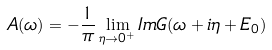Convert formula to latex. <formula><loc_0><loc_0><loc_500><loc_500>A ( \omega ) = - \frac { 1 } { \pi } \lim _ { \eta \to 0 ^ { + } } I m G ( \omega + i \eta + E _ { 0 } )</formula> 